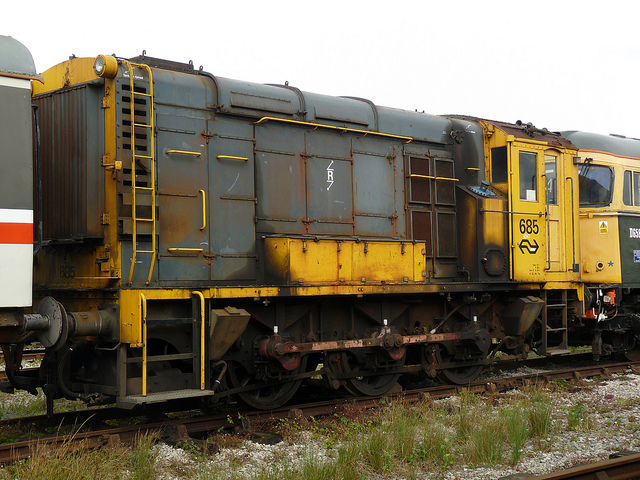Read and extract the text from this image. R 685 